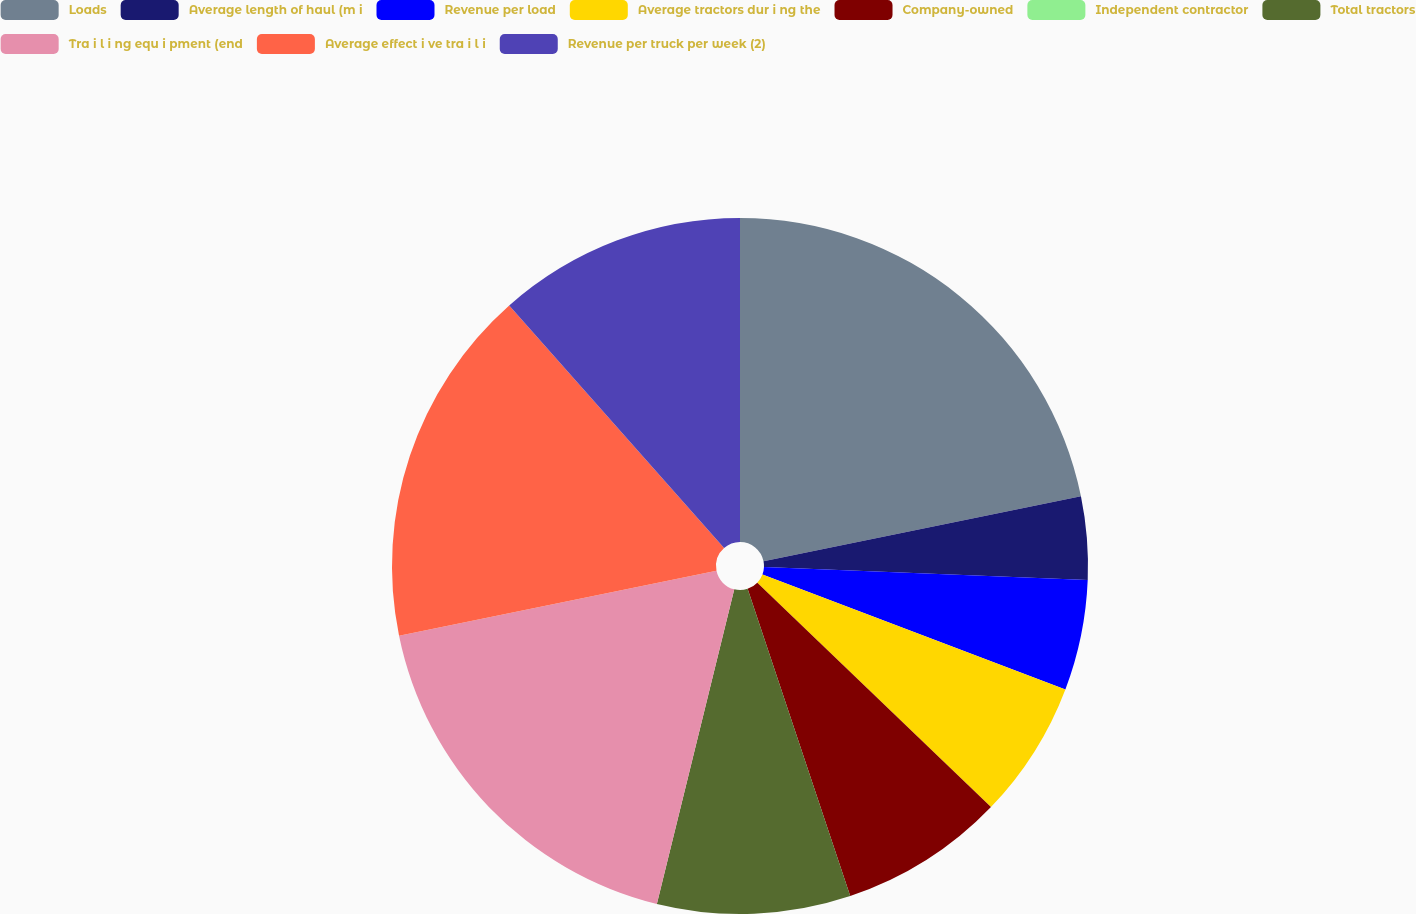Convert chart to OTSL. <chart><loc_0><loc_0><loc_500><loc_500><pie_chart><fcel>Loads<fcel>Average length of haul (m i<fcel>Revenue per load<fcel>Average tractors dur i ng the<fcel>Company-owned<fcel>Independent contractor<fcel>Total tractors<fcel>Tra i l i ng equ i pment (end<fcel>Average effect i ve tra i l i<fcel>Revenue per truck per week (2)<nl><fcel>21.79%<fcel>3.85%<fcel>5.13%<fcel>6.41%<fcel>7.69%<fcel>0.0%<fcel>8.97%<fcel>17.95%<fcel>16.67%<fcel>11.54%<nl></chart> 